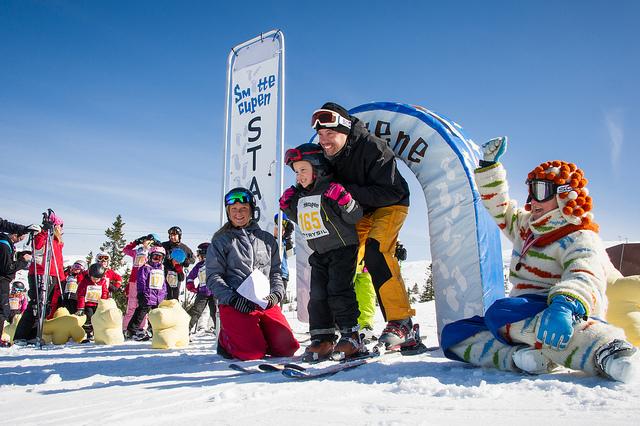What stands out about the man in the middle?
Be succinct. Yellow pants. What are they wearing?
Answer briefly. Skis. Is this a ski tournament?
Keep it brief. Yes. Is the child keeping the man from falling?
Give a very brief answer. No. 